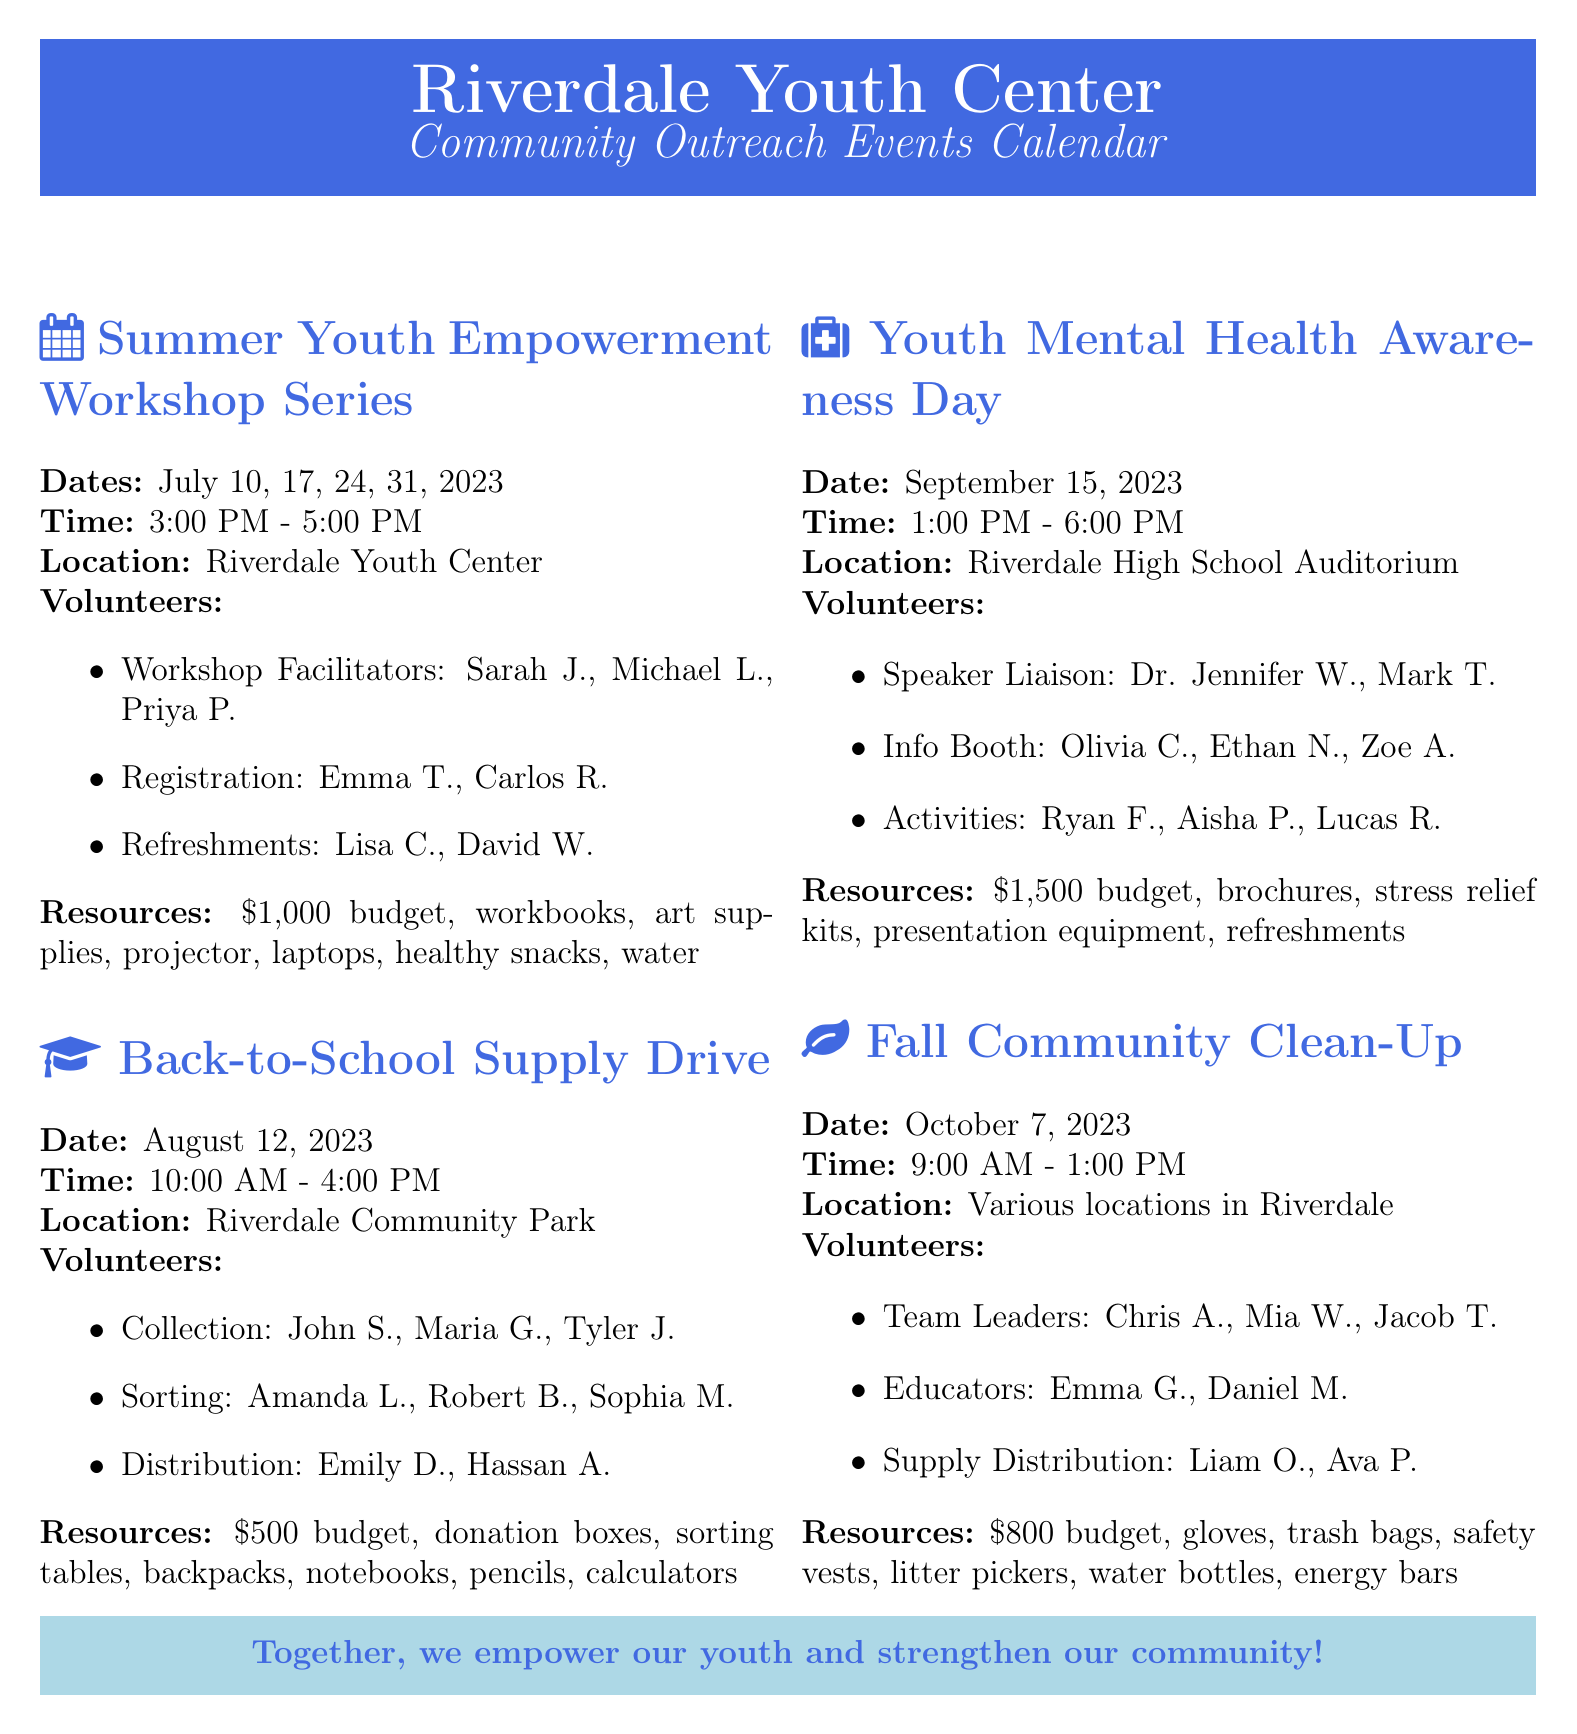what is the first event in the calendar? The first event listed in the calendar is the "Summer Youth Empowerment Workshop Series."
Answer: Summer Youth Empowerment Workshop Series how many days does the Summer Youth Empowerment Workshop Series run? The event runs on four different days: July 10, 17, 24, and 31, 2023.
Answer: 4 what is the budget for the Fall Community Clean-Up? The budget allocated for the Fall Community Clean-Up is clearly stated in the document.
Answer: $800 who are the volunteer workshop facilitators for the first event? The document lists three volunteers under the role of Workshop Facilitator for the first event.
Answer: Sarah Johnson, Michael Lee, Priya Patel what is the time duration for the Youth Mental Health Awareness Day? The time mentioned for the event is from 1:00 PM to 6:00 PM, indicating a duration.
Answer: 5 hours how many volunteer roles are assigned for the Back-to-School Supply Drive? By counting the roles listed for the Back-to-School Supply Drive, we can determine the number of volunteer roles.
Answer: 3 which event has the most significant budget allocation? By comparing the budgets of the listed events, we can identify the largest one.
Answer: $1,500 what location is designated for the Youth Mental Health Awareness Day? The location is specified for this event, provided in the document.
Answer: Riverdale High School Auditorium what items are included in the resource allocation for the Summer Youth Empowerment Workshop Series? The document mentions several materials allocated for this event.
Answer: Workbooks, Art supplies, Projector, Laptops, Healthy snacks, Bottled water 